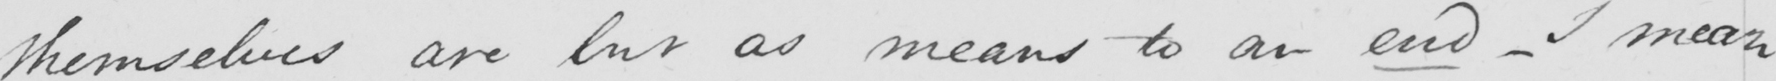What text is written in this handwritten line? themselves are but as means to an end  _  I mean 